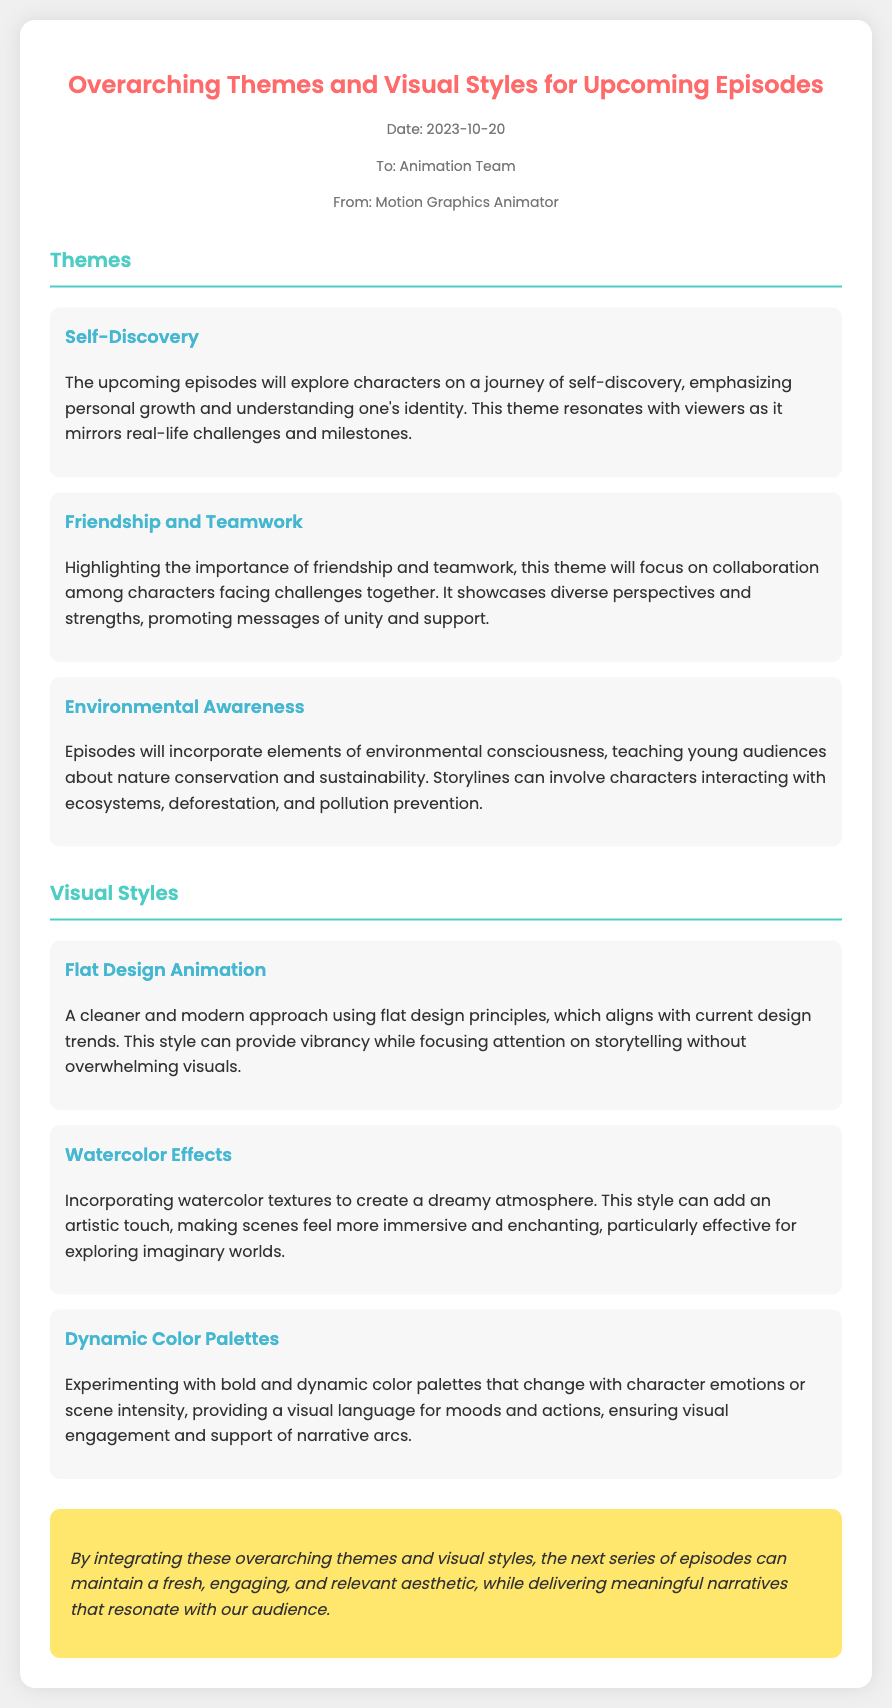What is the date of the memo? The date of the memo is stated in the document's header.
Answer: 2023-10-20 Who is the memo addressed to? The recipient of the memo is mentioned in the meta section.
Answer: Animation Team What theme explores characters on a journey of personal growth? The themes section lists several themes, including one focused on personal growth.
Answer: Self-Discovery Which visual style incorporates bold color palettes? The document includes specific visual styles with descriptions, one of which mentions bold color palettes.
Answer: Dynamic Color Palettes What is the overarching theme related to nature? The themes section discusses various themes, including one related to the environment.
Answer: Environmental Awareness What type of animation is described as a modern approach with flat design? The visual styles section contains a description of a style focused on flat design principles.
Answer: Flat Design Animation How many themes are mentioned in the document? The count of themes is provided explicitly within the themes section of the document.
Answer: Three What is the purpose of the conclusion section? The conclusion states the overall intent and summary of the proposed themes and styles for the episodes.
Answer: To maintain a fresh, engaging, and relevant aesthetic 